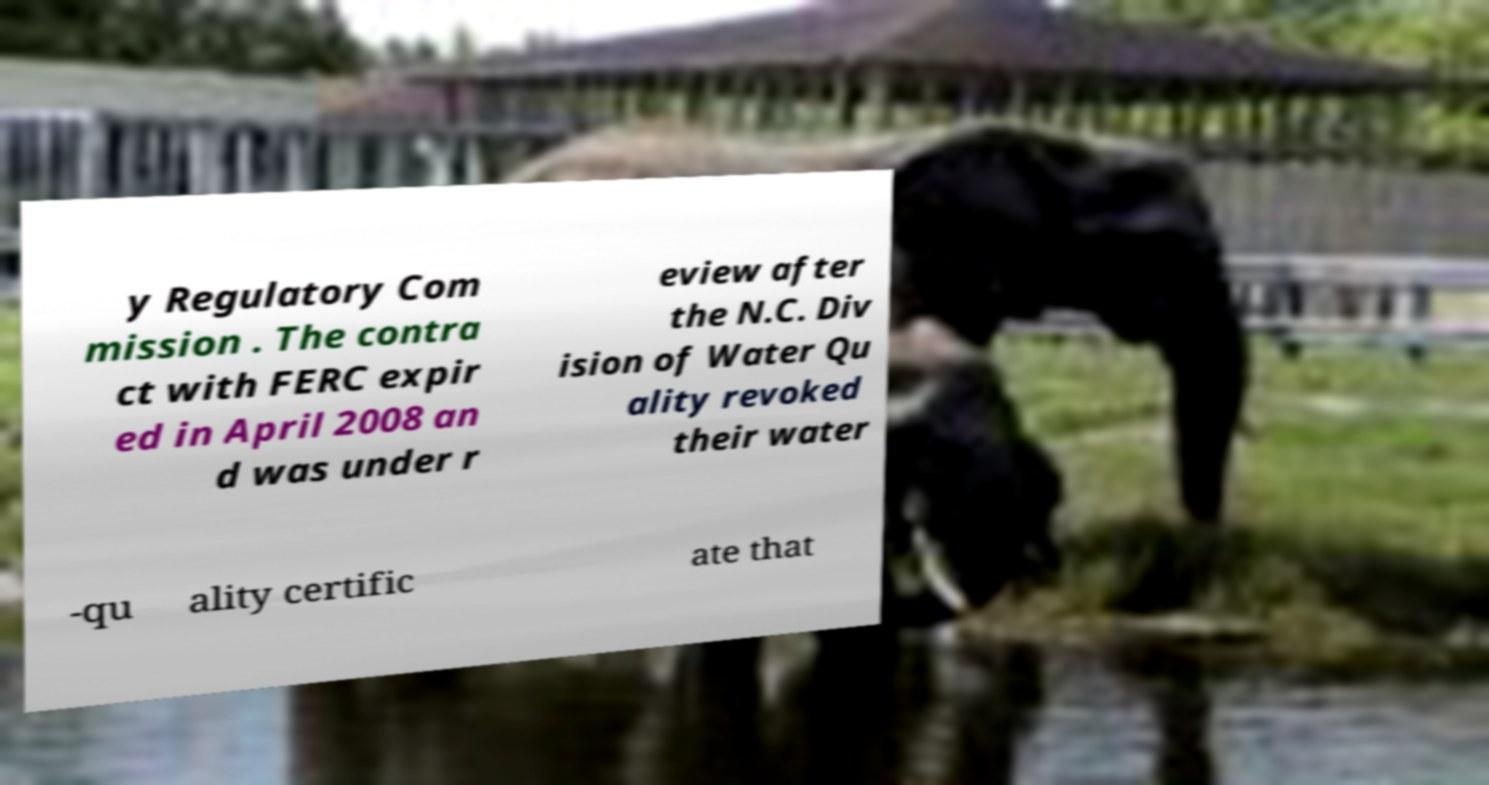I need the written content from this picture converted into text. Can you do that? y Regulatory Com mission . The contra ct with FERC expir ed in April 2008 an d was under r eview after the N.C. Div ision of Water Qu ality revoked their water -qu ality certific ate that 